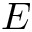<formula> <loc_0><loc_0><loc_500><loc_500>E</formula> 